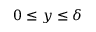<formula> <loc_0><loc_0><loc_500><loc_500>0 \leq y \leq \delta</formula> 